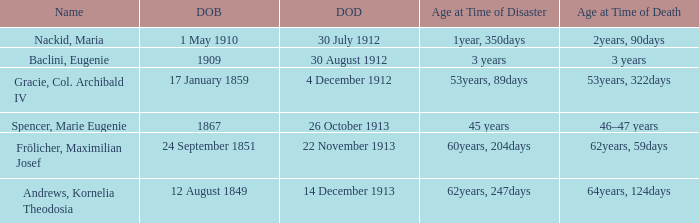What is the name of the person born in 1909? Baclini, Eugenie. 